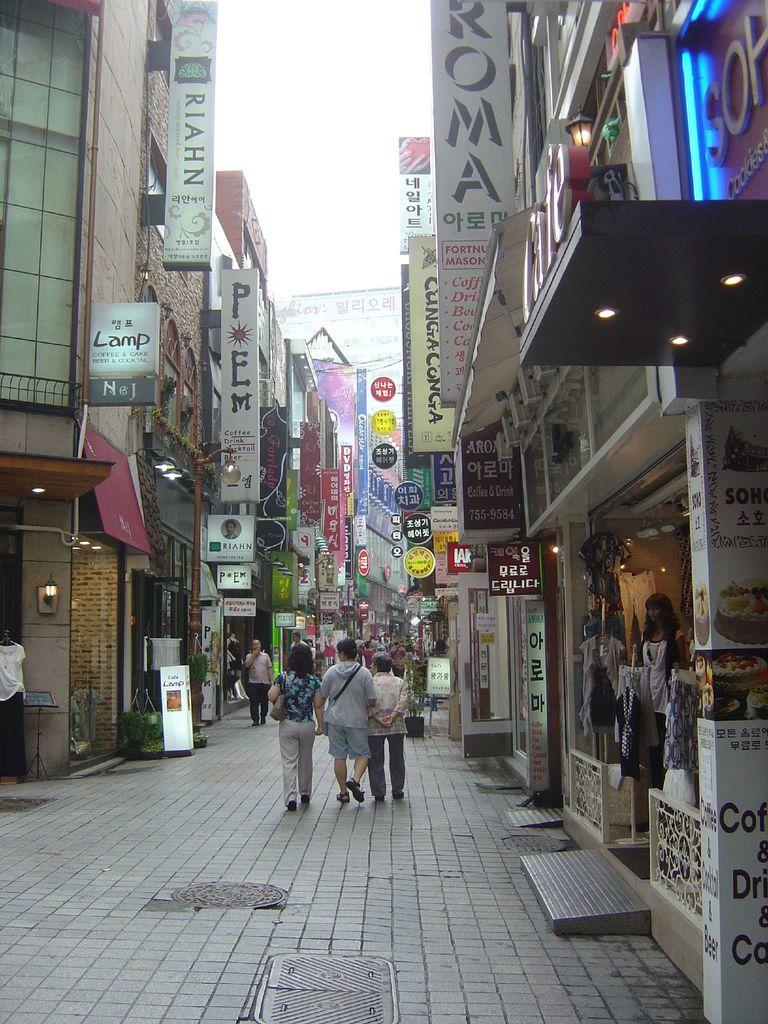What type of structures can be seen in the image? There are buildings in the image. What type of vegetation is present in the image? There are potted plants in the image. What type of illumination is visible in the image? There are lights in the image. What type of living beings can be seen in the image? There are people in the image. What type of items are present in the image related to clothing? There are clothes in the image. What type of signage is present in the image? There are boards with text in the image. What can be seen in the background of the image? The sky is visible in the background of the image. What type of jam is being spread on the mouth of the sheep in the image? There is no sheep or jam present in the image. What type of mouth can be seen on the buildings in the image? Buildings do not have mouths, as they are inanimate structures. 